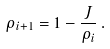Convert formula to latex. <formula><loc_0><loc_0><loc_500><loc_500>\rho _ { i + 1 } = 1 - \frac { J } { \rho _ { i } } \, .</formula> 